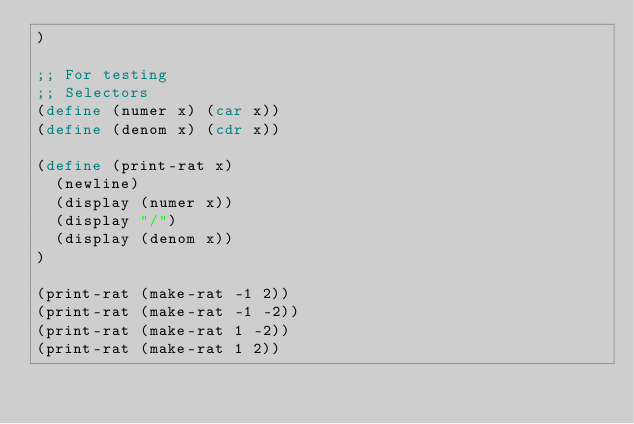Convert code to text. <code><loc_0><loc_0><loc_500><loc_500><_Scheme_>)

;; For testing
;; Selectors
(define (numer x) (car x))
(define (denom x) (cdr x))

(define (print-rat x)
  (newline)
  (display (numer x))
  (display "/")
  (display (denom x))
)

(print-rat (make-rat -1 2))
(print-rat (make-rat -1 -2))
(print-rat (make-rat 1 -2))
(print-rat (make-rat 1 2))</code> 